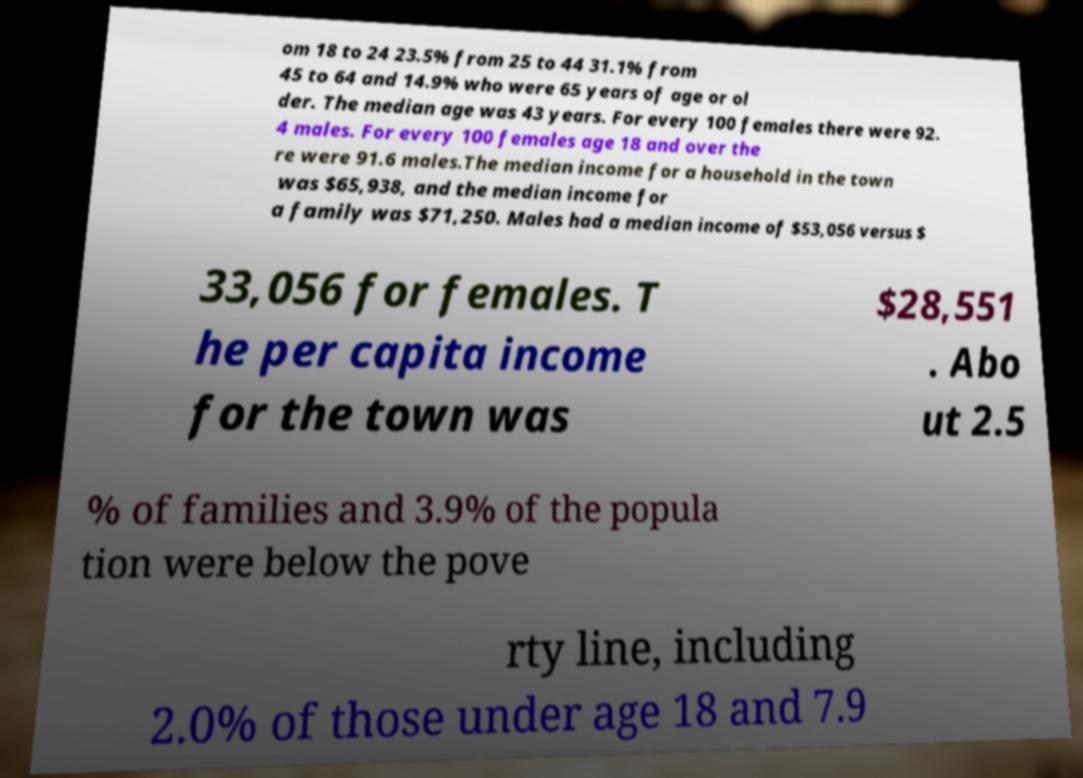What messages or text are displayed in this image? I need them in a readable, typed format. om 18 to 24 23.5% from 25 to 44 31.1% from 45 to 64 and 14.9% who were 65 years of age or ol der. The median age was 43 years. For every 100 females there were 92. 4 males. For every 100 females age 18 and over the re were 91.6 males.The median income for a household in the town was $65,938, and the median income for a family was $71,250. Males had a median income of $53,056 versus $ 33,056 for females. T he per capita income for the town was $28,551 . Abo ut 2.5 % of families and 3.9% of the popula tion were below the pove rty line, including 2.0% of those under age 18 and 7.9 